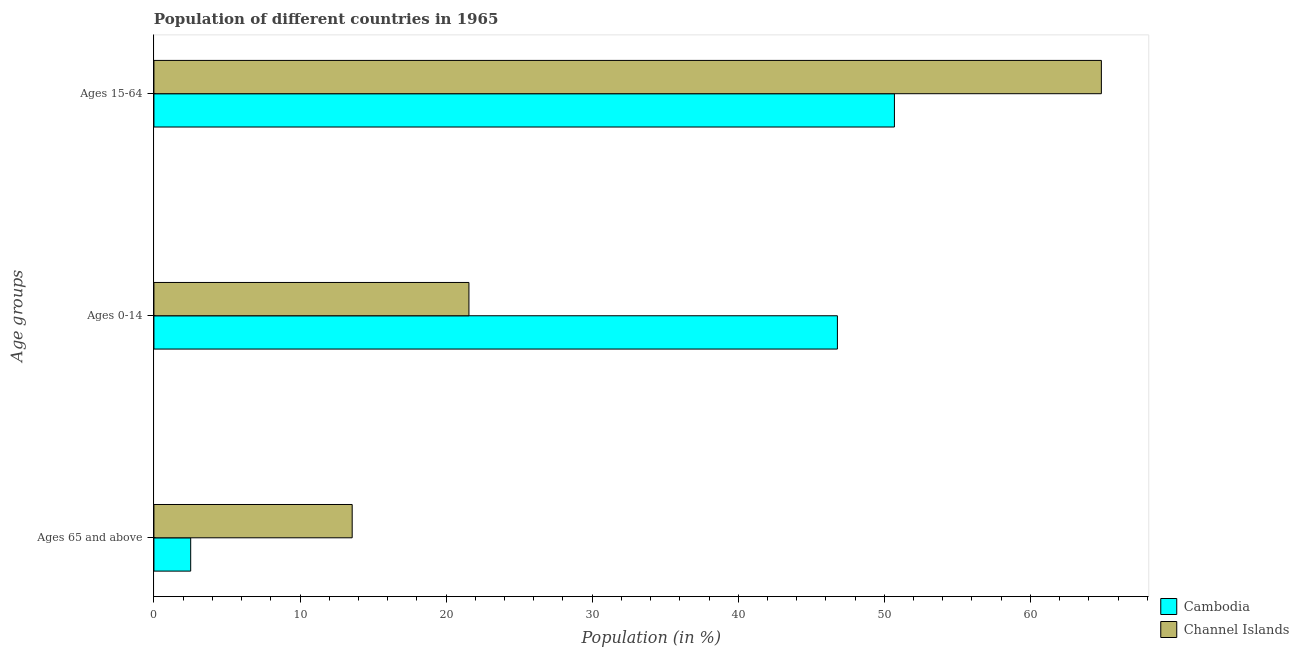How many bars are there on the 1st tick from the bottom?
Give a very brief answer. 2. What is the label of the 2nd group of bars from the top?
Keep it short and to the point. Ages 0-14. What is the percentage of population within the age-group of 65 and above in Channel Islands?
Make the answer very short. 13.57. Across all countries, what is the maximum percentage of population within the age-group 0-14?
Provide a succinct answer. 46.79. Across all countries, what is the minimum percentage of population within the age-group 0-14?
Make the answer very short. 21.57. In which country was the percentage of population within the age-group of 65 and above maximum?
Give a very brief answer. Channel Islands. In which country was the percentage of population within the age-group 15-64 minimum?
Provide a short and direct response. Cambodia. What is the total percentage of population within the age-group 15-64 in the graph?
Your response must be concise. 115.55. What is the difference between the percentage of population within the age-group 15-64 in Cambodia and that in Channel Islands?
Provide a succinct answer. -14.17. What is the difference between the percentage of population within the age-group of 65 and above in Channel Islands and the percentage of population within the age-group 0-14 in Cambodia?
Your response must be concise. -33.22. What is the average percentage of population within the age-group 15-64 per country?
Your response must be concise. 57.78. What is the difference between the percentage of population within the age-group of 65 and above and percentage of population within the age-group 0-14 in Cambodia?
Offer a very short reply. -44.27. What is the ratio of the percentage of population within the age-group 15-64 in Cambodia to that in Channel Islands?
Your answer should be compact. 0.78. Is the difference between the percentage of population within the age-group 0-14 in Cambodia and Channel Islands greater than the difference between the percentage of population within the age-group 15-64 in Cambodia and Channel Islands?
Your response must be concise. Yes. What is the difference between the highest and the second highest percentage of population within the age-group of 65 and above?
Ensure brevity in your answer.  11.06. What is the difference between the highest and the lowest percentage of population within the age-group of 65 and above?
Ensure brevity in your answer.  11.06. Is the sum of the percentage of population within the age-group of 65 and above in Cambodia and Channel Islands greater than the maximum percentage of population within the age-group 15-64 across all countries?
Your response must be concise. No. What does the 1st bar from the top in Ages 15-64 represents?
Offer a terse response. Channel Islands. What does the 1st bar from the bottom in Ages 15-64 represents?
Ensure brevity in your answer.  Cambodia. Is it the case that in every country, the sum of the percentage of population within the age-group of 65 and above and percentage of population within the age-group 0-14 is greater than the percentage of population within the age-group 15-64?
Your answer should be compact. No. How many bars are there?
Your response must be concise. 6. Are the values on the major ticks of X-axis written in scientific E-notation?
Ensure brevity in your answer.  No. How many legend labels are there?
Ensure brevity in your answer.  2. How are the legend labels stacked?
Provide a short and direct response. Vertical. What is the title of the graph?
Give a very brief answer. Population of different countries in 1965. What is the label or title of the X-axis?
Your answer should be compact. Population (in %). What is the label or title of the Y-axis?
Provide a short and direct response. Age groups. What is the Population (in %) of Cambodia in Ages 65 and above?
Offer a terse response. 2.52. What is the Population (in %) of Channel Islands in Ages 65 and above?
Make the answer very short. 13.57. What is the Population (in %) in Cambodia in Ages 0-14?
Keep it short and to the point. 46.79. What is the Population (in %) in Channel Islands in Ages 0-14?
Offer a very short reply. 21.57. What is the Population (in %) in Cambodia in Ages 15-64?
Ensure brevity in your answer.  50.69. What is the Population (in %) in Channel Islands in Ages 15-64?
Ensure brevity in your answer.  64.86. Across all Age groups, what is the maximum Population (in %) in Cambodia?
Keep it short and to the point. 50.69. Across all Age groups, what is the maximum Population (in %) in Channel Islands?
Ensure brevity in your answer.  64.86. Across all Age groups, what is the minimum Population (in %) of Cambodia?
Give a very brief answer. 2.52. Across all Age groups, what is the minimum Population (in %) of Channel Islands?
Give a very brief answer. 13.57. What is the difference between the Population (in %) of Cambodia in Ages 65 and above and that in Ages 0-14?
Ensure brevity in your answer.  -44.27. What is the difference between the Population (in %) of Channel Islands in Ages 65 and above and that in Ages 0-14?
Your answer should be compact. -7.99. What is the difference between the Population (in %) in Cambodia in Ages 65 and above and that in Ages 15-64?
Provide a succinct answer. -48.18. What is the difference between the Population (in %) of Channel Islands in Ages 65 and above and that in Ages 15-64?
Make the answer very short. -51.29. What is the difference between the Population (in %) of Cambodia in Ages 0-14 and that in Ages 15-64?
Your answer should be compact. -3.9. What is the difference between the Population (in %) of Channel Islands in Ages 0-14 and that in Ages 15-64?
Ensure brevity in your answer.  -43.3. What is the difference between the Population (in %) of Cambodia in Ages 65 and above and the Population (in %) of Channel Islands in Ages 0-14?
Provide a succinct answer. -19.05. What is the difference between the Population (in %) in Cambodia in Ages 65 and above and the Population (in %) in Channel Islands in Ages 15-64?
Keep it short and to the point. -62.34. What is the difference between the Population (in %) of Cambodia in Ages 0-14 and the Population (in %) of Channel Islands in Ages 15-64?
Provide a short and direct response. -18.07. What is the average Population (in %) of Cambodia per Age groups?
Give a very brief answer. 33.33. What is the average Population (in %) of Channel Islands per Age groups?
Ensure brevity in your answer.  33.33. What is the difference between the Population (in %) of Cambodia and Population (in %) of Channel Islands in Ages 65 and above?
Keep it short and to the point. -11.06. What is the difference between the Population (in %) of Cambodia and Population (in %) of Channel Islands in Ages 0-14?
Provide a short and direct response. 25.22. What is the difference between the Population (in %) of Cambodia and Population (in %) of Channel Islands in Ages 15-64?
Ensure brevity in your answer.  -14.17. What is the ratio of the Population (in %) of Cambodia in Ages 65 and above to that in Ages 0-14?
Your response must be concise. 0.05. What is the ratio of the Population (in %) of Channel Islands in Ages 65 and above to that in Ages 0-14?
Your answer should be very brief. 0.63. What is the ratio of the Population (in %) of Cambodia in Ages 65 and above to that in Ages 15-64?
Your answer should be compact. 0.05. What is the ratio of the Population (in %) of Channel Islands in Ages 65 and above to that in Ages 15-64?
Provide a succinct answer. 0.21. What is the ratio of the Population (in %) in Cambodia in Ages 0-14 to that in Ages 15-64?
Keep it short and to the point. 0.92. What is the ratio of the Population (in %) in Channel Islands in Ages 0-14 to that in Ages 15-64?
Your answer should be compact. 0.33. What is the difference between the highest and the second highest Population (in %) of Cambodia?
Your response must be concise. 3.9. What is the difference between the highest and the second highest Population (in %) in Channel Islands?
Offer a terse response. 43.3. What is the difference between the highest and the lowest Population (in %) in Cambodia?
Provide a succinct answer. 48.18. What is the difference between the highest and the lowest Population (in %) in Channel Islands?
Your answer should be very brief. 51.29. 